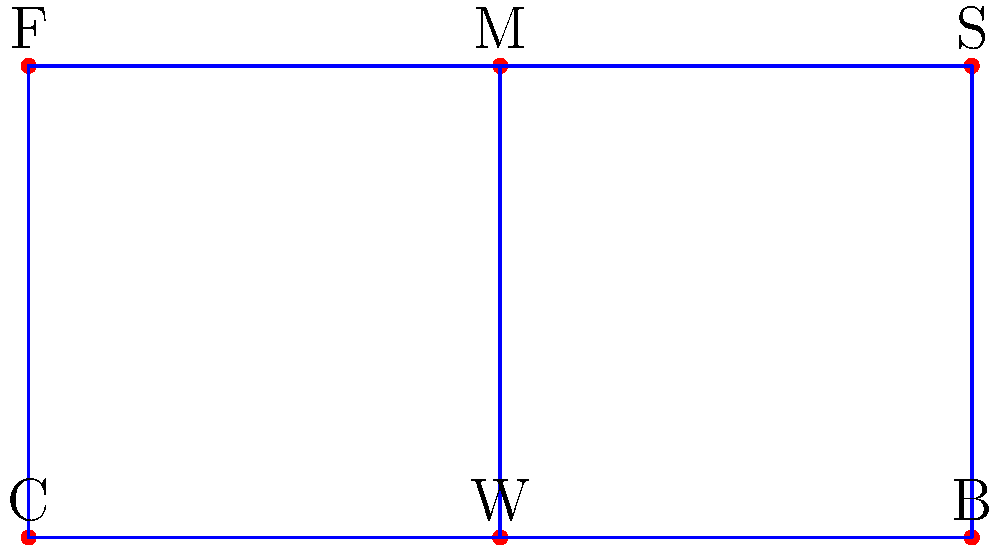Consider the following group theory diagram representing a cricket team formation. The positions are labeled as C (Captain), W (Wicketkeeper), B (Bowler), F (Fielder), M (Mid-fielder), and S (Spin bowler). If we apply the group operation of rotation by 180 degrees around the center point between W and M, which of the following statements is true?

a) The operation forms a cyclic group of order 2
b) The operation forms a cyclic group of order 3
c) The operation forms a cyclic group of order 6
d) The operation does not form a group Let's approach this step-by-step:

1) First, we need to understand what a 180-degree rotation around the center point between W and M does to the formation:
   - C swaps with S
   - W swaps with M
   - B swaps with F

2) Let's call this rotation operation R. We need to check if it satisfies the group axioms:

   a) Closure: Applying R twice brings us back to the original formation. So R • R = I (identity).
   b) Associativity: This is inherent in geometric transformations.
   c) Identity: The identity operation (no rotation) exists.
   d) Inverse: R is its own inverse, as R • R = I.

3) Since all group axioms are satisfied, this operation does form a group.

4) To determine the order of the group:
   - R • R = I
   - This means that the group has two elements: {I, R}

5) A group with two elements is a cyclic group of order 2.

Therefore, the operation forms a cyclic group of order 2.
Answer: a) The operation forms a cyclic group of order 2 